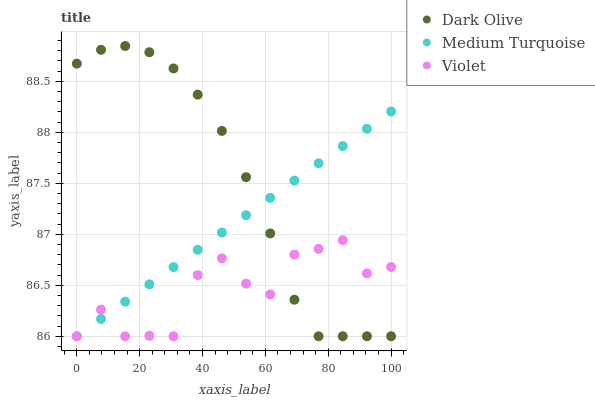Does Violet have the minimum area under the curve?
Answer yes or no. Yes. Does Dark Olive have the maximum area under the curve?
Answer yes or no. Yes. Does Medium Turquoise have the minimum area under the curve?
Answer yes or no. No. Does Medium Turquoise have the maximum area under the curve?
Answer yes or no. No. Is Medium Turquoise the smoothest?
Answer yes or no. Yes. Is Violet the roughest?
Answer yes or no. Yes. Is Violet the smoothest?
Answer yes or no. No. Is Medium Turquoise the roughest?
Answer yes or no. No. Does Dark Olive have the lowest value?
Answer yes or no. Yes. Does Dark Olive have the highest value?
Answer yes or no. Yes. Does Medium Turquoise have the highest value?
Answer yes or no. No. Does Medium Turquoise intersect Violet?
Answer yes or no. Yes. Is Medium Turquoise less than Violet?
Answer yes or no. No. Is Medium Turquoise greater than Violet?
Answer yes or no. No. 